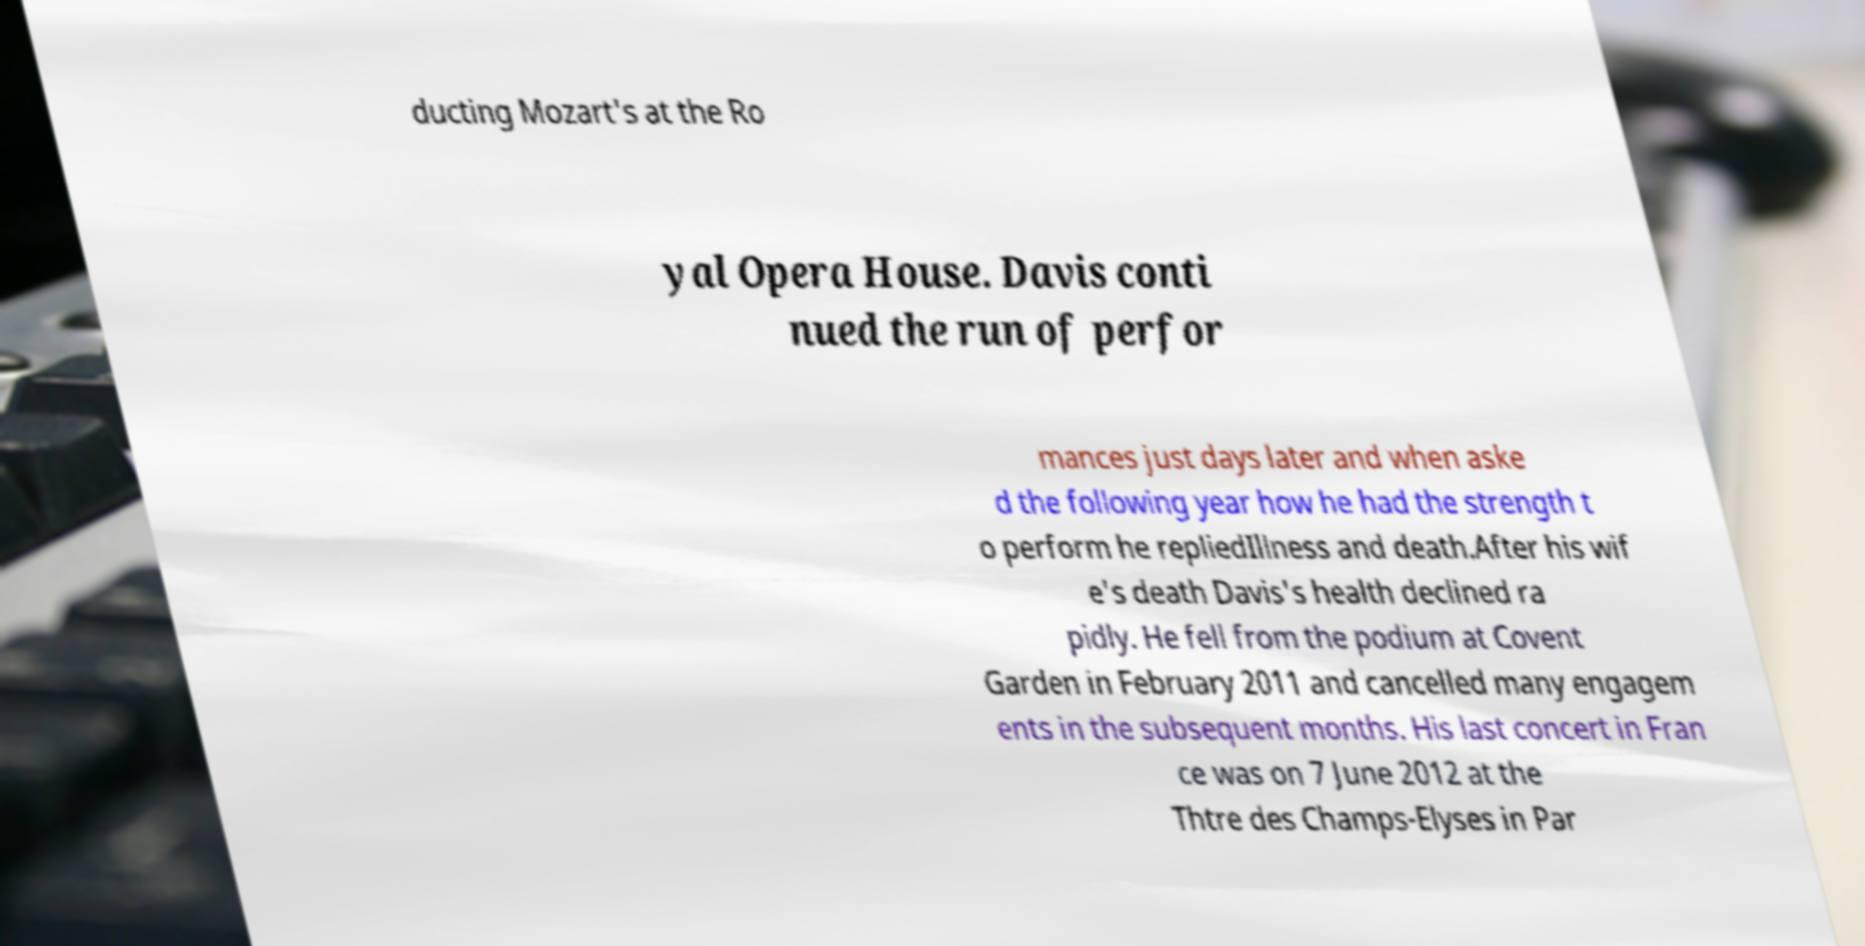Could you extract and type out the text from this image? ducting Mozart's at the Ro yal Opera House. Davis conti nued the run of perfor mances just days later and when aske d the following year how he had the strength t o perform he repliedIllness and death.After his wif e's death Davis's health declined ra pidly. He fell from the podium at Covent Garden in February 2011 and cancelled many engagem ents in the subsequent months. His last concert in Fran ce was on 7 June 2012 at the Thtre des Champs-Elyses in Par 